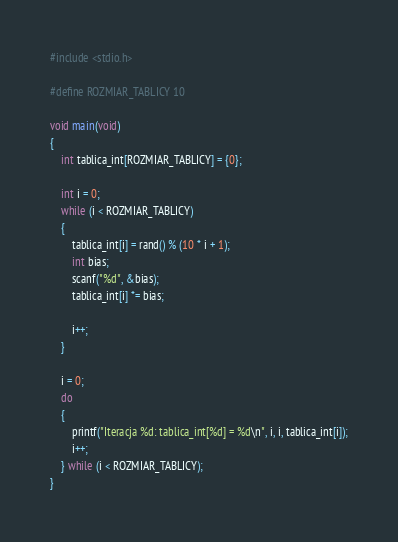<code> <loc_0><loc_0><loc_500><loc_500><_C_>#include <stdio.h>

#define ROZMIAR_TABLICY 10

void main(void)
{
    int tablica_int[ROZMIAR_TABLICY] = {0};

    int i = 0;
    while (i < ROZMIAR_TABLICY)
    {
        tablica_int[i] = rand() % (10 * i + 1);
        int bias;
        scanf("%d", &bias);
        tablica_int[i] *= bias;

        i++;
    }

    i = 0;
    do
    {
        printf("Iteracja %d: tablica_int[%d] = %d\n", i, i, tablica_int[i]);
        i++;
    } while (i < ROZMIAR_TABLICY);
}
</code> 